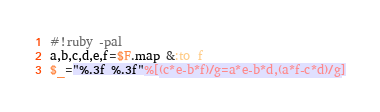<code> <loc_0><loc_0><loc_500><loc_500><_Ruby_>#!ruby -pal
a,b,c,d,e,f=$F.map &:to_f
$_="%.3f %.3f"%[(c*e-b*f)/g=a*e-b*d,(a*f-c*d)/g]</code> 